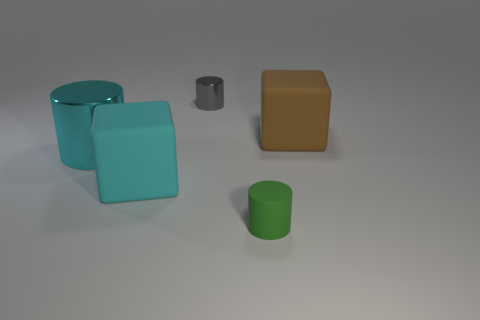There is another object that is the same color as the big metallic object; what size is it?
Give a very brief answer. Large. What is the shape of the thing that is the same color as the big cylinder?
Ensure brevity in your answer.  Cube. Does the small green cylinder have the same material as the big brown object that is behind the tiny green thing?
Keep it short and to the point. Yes. How many other things are the same shape as the large brown rubber thing?
Provide a short and direct response. 1. What material is the tiny cylinder that is behind the rubber cube on the right side of the cube to the left of the brown rubber block made of?
Your response must be concise. Metal. Are there an equal number of metallic things that are on the right side of the gray thing and metallic things?
Give a very brief answer. No. Do the large block to the left of the small green thing and the big block to the right of the tiny rubber object have the same material?
Offer a very short reply. Yes. Do the matte thing that is on the left side of the gray shiny cylinder and the large matte thing to the right of the cyan cube have the same shape?
Ensure brevity in your answer.  Yes. Is the number of metal objects behind the large cyan metallic cylinder less than the number of blue rubber blocks?
Provide a short and direct response. No. What number of tiny cubes have the same color as the big metal object?
Offer a very short reply. 0. 